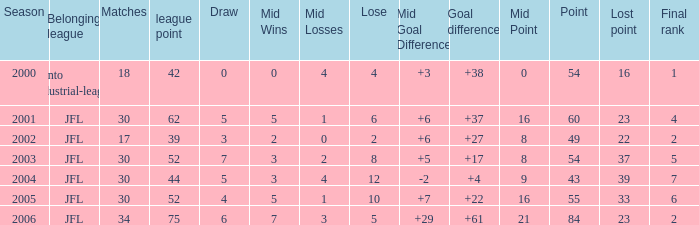Provide the median ending placement for loe above 10 and point fewer than 4 None. 